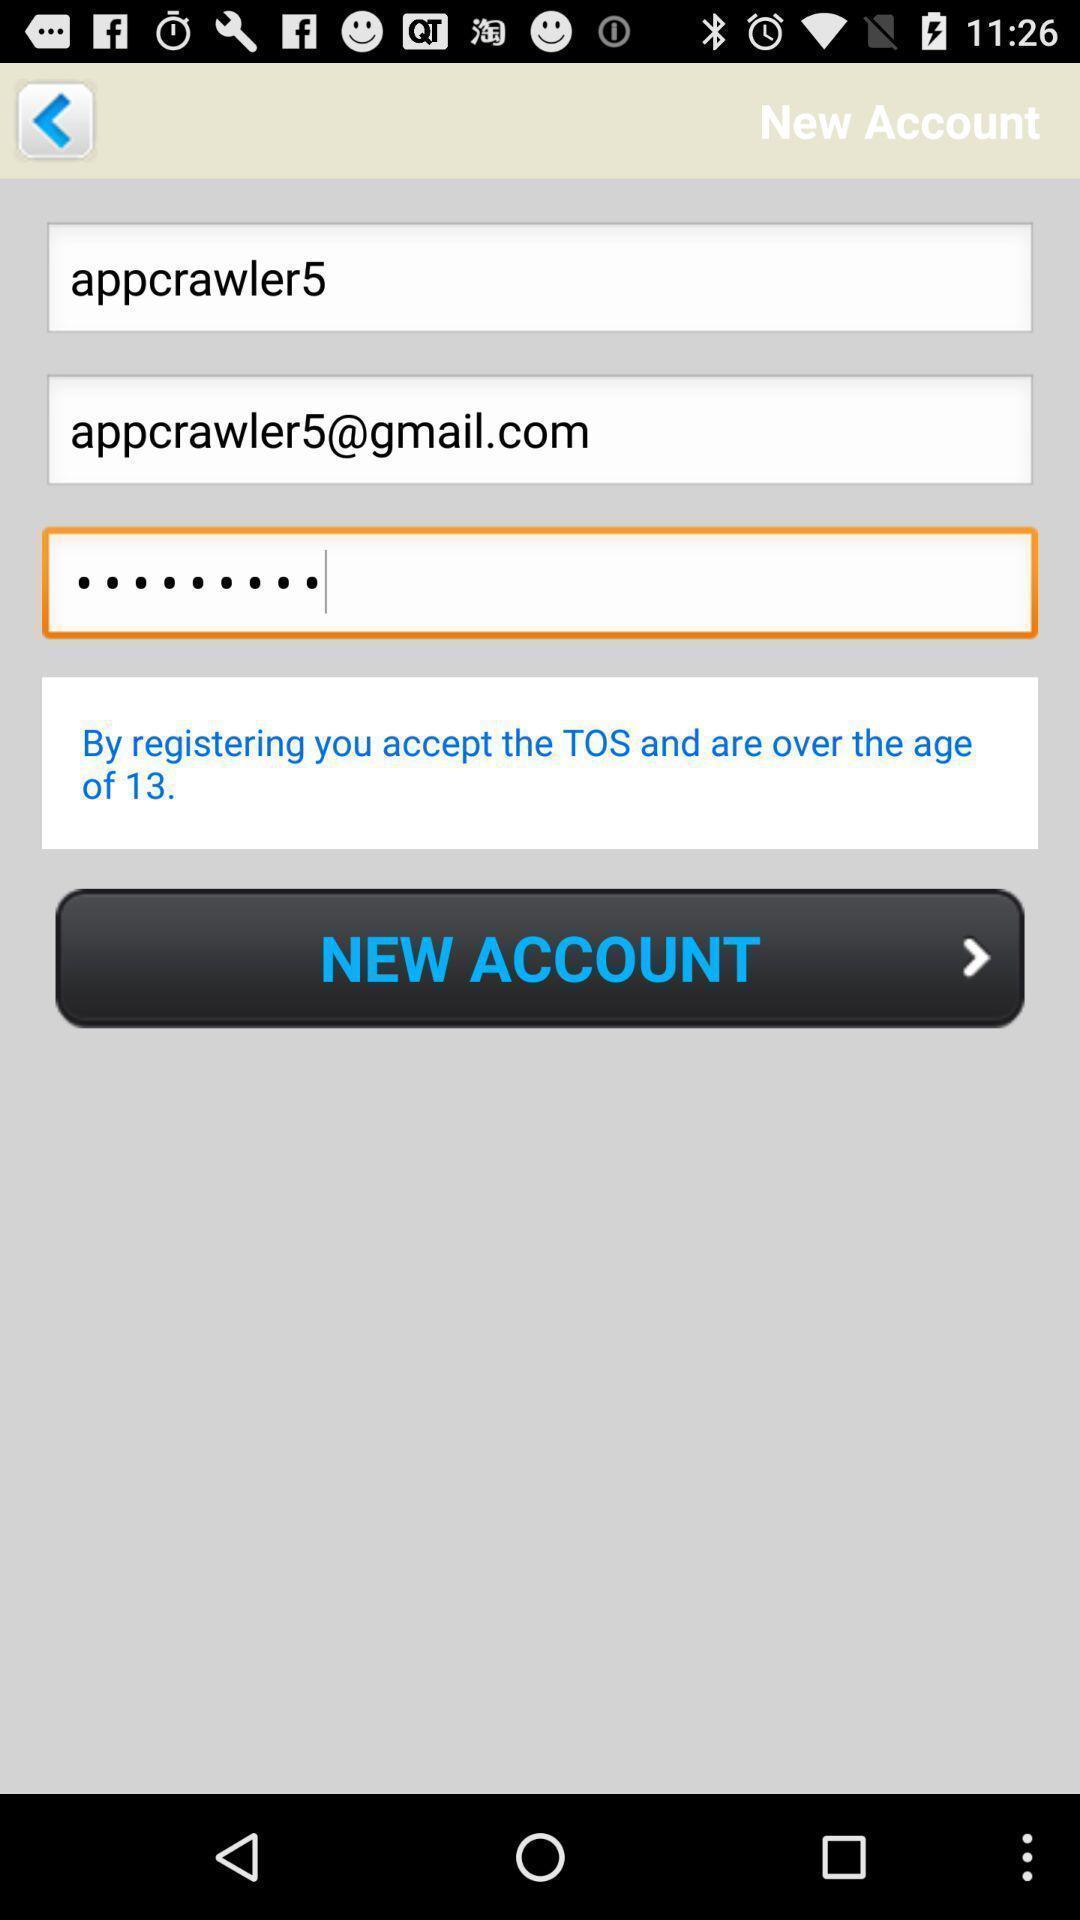Provide a detailed account of this screenshot. Screen shows new account details. 